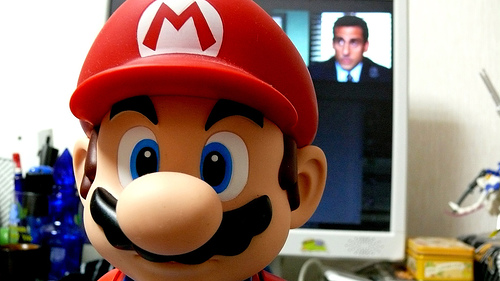<image>
Is the circle in front of the body? Yes. The circle is positioned in front of the body, appearing closer to the camera viewpoint. 